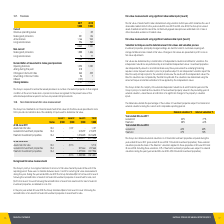According to National Storage Reit's financial document, What was the amount of transfer that the Group did from level 3 to level 2? According to the financial document, $2.1m. The relevant text states: "the year ended 30 June 2019 the Group transferred $2.1m from level 3 to level 2 following the reclassification of assets from freehold investment properties..." Also, How has the group valued the assets classified as held for sale in 2018 and 2019? classified as held for sale at the contractually agreed sales price less estimated cost of sale or other observable evidence of market value.. The document states: "2019 and 30 June 2018, the Group has valued assets classified as held for sale at the contractually agreed sales price less estimated cost of sale or ..." Also, What was the assets held for sale under Level 1, Level 2 and Level 3 in 2018? The document contains multiple relevant values: -, 5,713, - (in thousands). From the document: "Assets held for sale 10.2 - 5,713 - 5,713 Assets held for sale 10.2 - 5,713 - 5,713..." Also, can you calculate: What was the change in the assets held for sale under Level 2 from 2018 to 2019? Based on the calculation: 1,107 - 5,713, the result is -4606 (in thousands). This is based on the information: "Assets held for sale 10.2 - 1,107 - 1,107 Assets held for sale 10.2 - 5,713 - 5,713..." The key data points involved are: 1,107, 5,713. Additionally, In which year was Assets held for sale less than 2,000 thousands? According to the financial document, 2019. The relevant text states: "properties acquired during the year ended 30 June 2019 (year ended 30 June 2018: 19 freehold investment properties). These external valuations provide the..." Also, can you calculate: What is the average Leasehold investment properties for 2018 and 2019? To answer this question, I need to perform calculations using the financial data. The calculation is: (215,279 + 207,664) / 2, which equals 211471.5 (in thousands). This is based on the information: "Leasehold investment properties 10.4 - - 215,279 215,279 Leasehold investment properties 10.4 - - 207,664 207,664..." The key data points involved are: 207,664, 215,279. 